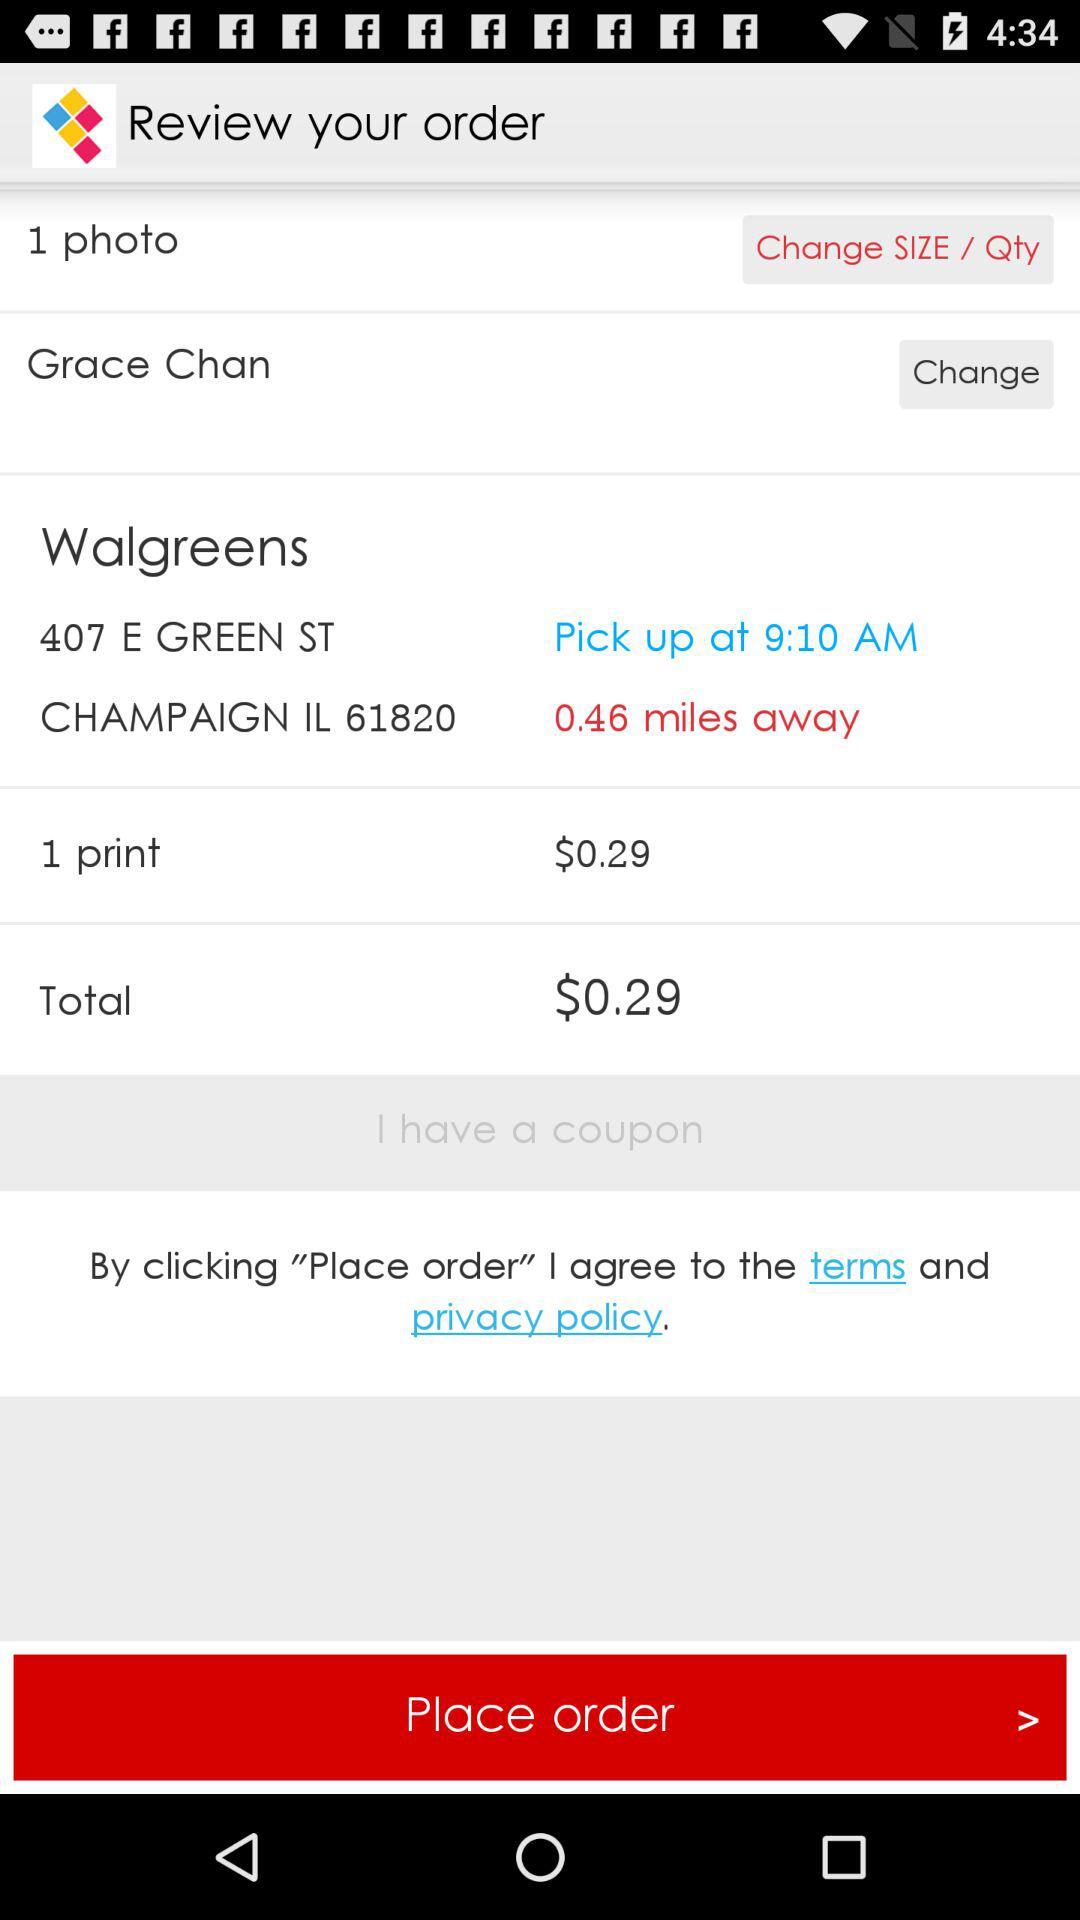How many items are in the cart?
Answer the question using a single word or phrase. 1 